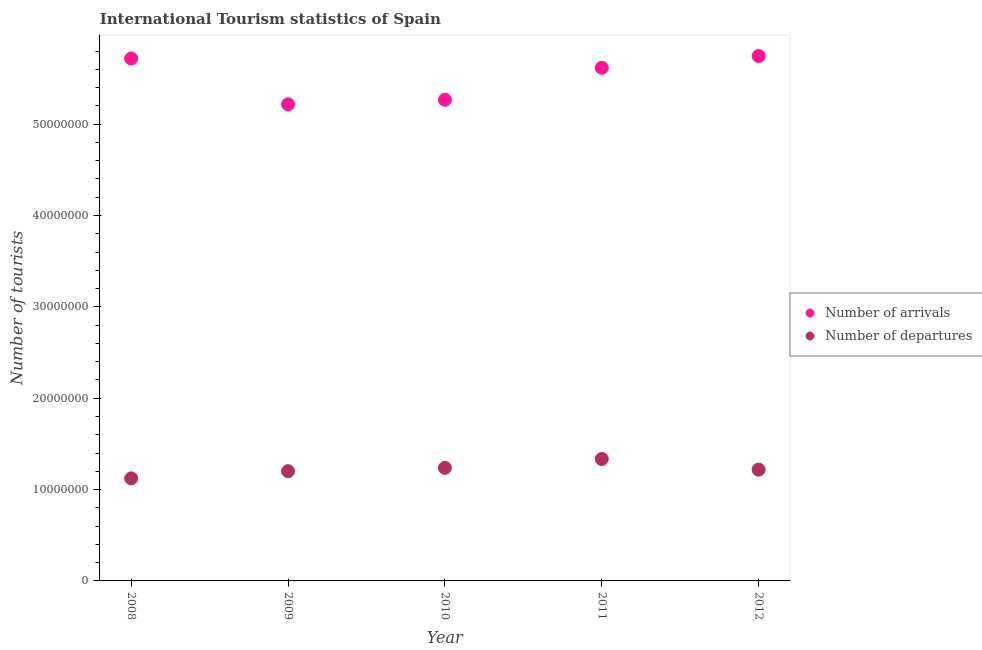Is the number of dotlines equal to the number of legend labels?
Offer a terse response. Yes. What is the number of tourist arrivals in 2008?
Your answer should be compact. 5.72e+07. Across all years, what is the maximum number of tourist arrivals?
Offer a terse response. 5.75e+07. Across all years, what is the minimum number of tourist arrivals?
Provide a succinct answer. 5.22e+07. In which year was the number of tourist arrivals maximum?
Provide a short and direct response. 2012. What is the total number of tourist arrivals in the graph?
Offer a very short reply. 2.76e+08. What is the difference between the number of tourist arrivals in 2009 and that in 2012?
Provide a succinct answer. -5.29e+06. What is the difference between the number of tourist arrivals in 2012 and the number of tourist departures in 2008?
Your response must be concise. 4.62e+07. What is the average number of tourist departures per year?
Your answer should be very brief. 1.22e+07. In the year 2008, what is the difference between the number of tourist departures and number of tourist arrivals?
Keep it short and to the point. -4.60e+07. What is the ratio of the number of tourist departures in 2009 to that in 2012?
Provide a succinct answer. 0.99. Is the number of tourist arrivals in 2008 less than that in 2010?
Give a very brief answer. No. Is the difference between the number of tourist arrivals in 2008 and 2009 greater than the difference between the number of tourist departures in 2008 and 2009?
Ensure brevity in your answer.  Yes. What is the difference between the highest and the second highest number of tourist arrivals?
Offer a very short reply. 2.72e+05. What is the difference between the highest and the lowest number of tourist arrivals?
Your answer should be compact. 5.29e+06. In how many years, is the number of tourist arrivals greater than the average number of tourist arrivals taken over all years?
Your answer should be compact. 3. Is the sum of the number of tourist arrivals in 2008 and 2010 greater than the maximum number of tourist departures across all years?
Your answer should be very brief. Yes. Does the number of tourist departures monotonically increase over the years?
Keep it short and to the point. No. Is the number of tourist arrivals strictly greater than the number of tourist departures over the years?
Your answer should be very brief. Yes. What is the difference between two consecutive major ticks on the Y-axis?
Your response must be concise. 1.00e+07. Does the graph contain grids?
Offer a terse response. No. How many legend labels are there?
Your response must be concise. 2. What is the title of the graph?
Your answer should be compact. International Tourism statistics of Spain. What is the label or title of the Y-axis?
Your answer should be very brief. Number of tourists. What is the Number of tourists in Number of arrivals in 2008?
Ensure brevity in your answer.  5.72e+07. What is the Number of tourists in Number of departures in 2008?
Keep it short and to the point. 1.12e+07. What is the Number of tourists in Number of arrivals in 2009?
Make the answer very short. 5.22e+07. What is the Number of tourists in Number of departures in 2009?
Make the answer very short. 1.20e+07. What is the Number of tourists of Number of arrivals in 2010?
Give a very brief answer. 5.27e+07. What is the Number of tourists in Number of departures in 2010?
Your answer should be very brief. 1.24e+07. What is the Number of tourists in Number of arrivals in 2011?
Your response must be concise. 5.62e+07. What is the Number of tourists of Number of departures in 2011?
Provide a short and direct response. 1.33e+07. What is the Number of tourists in Number of arrivals in 2012?
Offer a terse response. 5.75e+07. What is the Number of tourists of Number of departures in 2012?
Provide a short and direct response. 1.22e+07. Across all years, what is the maximum Number of tourists of Number of arrivals?
Your answer should be very brief. 5.75e+07. Across all years, what is the maximum Number of tourists of Number of departures?
Your answer should be compact. 1.33e+07. Across all years, what is the minimum Number of tourists of Number of arrivals?
Offer a very short reply. 5.22e+07. Across all years, what is the minimum Number of tourists of Number of departures?
Keep it short and to the point. 1.12e+07. What is the total Number of tourists in Number of arrivals in the graph?
Offer a terse response. 2.76e+08. What is the total Number of tourists in Number of departures in the graph?
Your answer should be very brief. 6.12e+07. What is the difference between the Number of tourists of Number of arrivals in 2008 and that in 2009?
Ensure brevity in your answer.  5.01e+06. What is the difference between the Number of tourists in Number of departures in 2008 and that in 2009?
Give a very brief answer. -7.88e+05. What is the difference between the Number of tourists in Number of arrivals in 2008 and that in 2010?
Make the answer very short. 4.52e+06. What is the difference between the Number of tourists in Number of departures in 2008 and that in 2010?
Your answer should be very brief. -1.15e+06. What is the difference between the Number of tourists in Number of arrivals in 2008 and that in 2011?
Keep it short and to the point. 1.02e+06. What is the difference between the Number of tourists in Number of departures in 2008 and that in 2011?
Make the answer very short. -2.12e+06. What is the difference between the Number of tourists in Number of arrivals in 2008 and that in 2012?
Your answer should be compact. -2.72e+05. What is the difference between the Number of tourists in Number of departures in 2008 and that in 2012?
Keep it short and to the point. -9.56e+05. What is the difference between the Number of tourists of Number of arrivals in 2009 and that in 2010?
Your response must be concise. -4.99e+05. What is the difference between the Number of tourists of Number of departures in 2009 and that in 2010?
Offer a very short reply. -3.62e+05. What is the difference between the Number of tourists in Number of arrivals in 2009 and that in 2011?
Ensure brevity in your answer.  -4.00e+06. What is the difference between the Number of tourists of Number of departures in 2009 and that in 2011?
Make the answer very short. -1.33e+06. What is the difference between the Number of tourists in Number of arrivals in 2009 and that in 2012?
Provide a short and direct response. -5.29e+06. What is the difference between the Number of tourists of Number of departures in 2009 and that in 2012?
Ensure brevity in your answer.  -1.68e+05. What is the difference between the Number of tourists in Number of arrivals in 2010 and that in 2011?
Your response must be concise. -3.50e+06. What is the difference between the Number of tourists in Number of departures in 2010 and that in 2011?
Offer a very short reply. -9.68e+05. What is the difference between the Number of tourists of Number of arrivals in 2010 and that in 2012?
Offer a terse response. -4.79e+06. What is the difference between the Number of tourists of Number of departures in 2010 and that in 2012?
Offer a terse response. 1.94e+05. What is the difference between the Number of tourists in Number of arrivals in 2011 and that in 2012?
Your answer should be very brief. -1.29e+06. What is the difference between the Number of tourists of Number of departures in 2011 and that in 2012?
Your answer should be compact. 1.16e+06. What is the difference between the Number of tourists of Number of arrivals in 2008 and the Number of tourists of Number of departures in 2009?
Your answer should be compact. 4.52e+07. What is the difference between the Number of tourists in Number of arrivals in 2008 and the Number of tourists in Number of departures in 2010?
Give a very brief answer. 4.48e+07. What is the difference between the Number of tourists in Number of arrivals in 2008 and the Number of tourists in Number of departures in 2011?
Keep it short and to the point. 4.38e+07. What is the difference between the Number of tourists in Number of arrivals in 2008 and the Number of tourists in Number of departures in 2012?
Offer a very short reply. 4.50e+07. What is the difference between the Number of tourists of Number of arrivals in 2009 and the Number of tourists of Number of departures in 2010?
Provide a succinct answer. 3.98e+07. What is the difference between the Number of tourists in Number of arrivals in 2009 and the Number of tourists in Number of departures in 2011?
Make the answer very short. 3.88e+07. What is the difference between the Number of tourists in Number of arrivals in 2009 and the Number of tourists in Number of departures in 2012?
Keep it short and to the point. 4.00e+07. What is the difference between the Number of tourists of Number of arrivals in 2010 and the Number of tourists of Number of departures in 2011?
Keep it short and to the point. 3.93e+07. What is the difference between the Number of tourists in Number of arrivals in 2010 and the Number of tourists in Number of departures in 2012?
Make the answer very short. 4.05e+07. What is the difference between the Number of tourists in Number of arrivals in 2011 and the Number of tourists in Number of departures in 2012?
Offer a terse response. 4.40e+07. What is the average Number of tourists in Number of arrivals per year?
Ensure brevity in your answer.  5.51e+07. What is the average Number of tourists of Number of departures per year?
Make the answer very short. 1.22e+07. In the year 2008, what is the difference between the Number of tourists in Number of arrivals and Number of tourists in Number of departures?
Your answer should be compact. 4.60e+07. In the year 2009, what is the difference between the Number of tourists in Number of arrivals and Number of tourists in Number of departures?
Your response must be concise. 4.02e+07. In the year 2010, what is the difference between the Number of tourists in Number of arrivals and Number of tourists in Number of departures?
Make the answer very short. 4.03e+07. In the year 2011, what is the difference between the Number of tourists of Number of arrivals and Number of tourists of Number of departures?
Give a very brief answer. 4.28e+07. In the year 2012, what is the difference between the Number of tourists in Number of arrivals and Number of tourists in Number of departures?
Your response must be concise. 4.53e+07. What is the ratio of the Number of tourists in Number of arrivals in 2008 to that in 2009?
Your response must be concise. 1.1. What is the ratio of the Number of tourists of Number of departures in 2008 to that in 2009?
Provide a short and direct response. 0.93. What is the ratio of the Number of tourists in Number of arrivals in 2008 to that in 2010?
Offer a very short reply. 1.09. What is the ratio of the Number of tourists of Number of departures in 2008 to that in 2010?
Your answer should be compact. 0.91. What is the ratio of the Number of tourists of Number of arrivals in 2008 to that in 2011?
Offer a very short reply. 1.02. What is the ratio of the Number of tourists in Number of departures in 2008 to that in 2011?
Your answer should be compact. 0.84. What is the ratio of the Number of tourists in Number of departures in 2008 to that in 2012?
Provide a short and direct response. 0.92. What is the ratio of the Number of tourists of Number of arrivals in 2009 to that in 2010?
Keep it short and to the point. 0.99. What is the ratio of the Number of tourists of Number of departures in 2009 to that in 2010?
Give a very brief answer. 0.97. What is the ratio of the Number of tourists of Number of arrivals in 2009 to that in 2011?
Offer a terse response. 0.93. What is the ratio of the Number of tourists in Number of departures in 2009 to that in 2011?
Ensure brevity in your answer.  0.9. What is the ratio of the Number of tourists of Number of arrivals in 2009 to that in 2012?
Provide a succinct answer. 0.91. What is the ratio of the Number of tourists of Number of departures in 2009 to that in 2012?
Your answer should be compact. 0.99. What is the ratio of the Number of tourists of Number of arrivals in 2010 to that in 2011?
Offer a terse response. 0.94. What is the ratio of the Number of tourists in Number of departures in 2010 to that in 2011?
Give a very brief answer. 0.93. What is the ratio of the Number of tourists of Number of departures in 2010 to that in 2012?
Your response must be concise. 1.02. What is the ratio of the Number of tourists of Number of arrivals in 2011 to that in 2012?
Make the answer very short. 0.98. What is the ratio of the Number of tourists of Number of departures in 2011 to that in 2012?
Provide a short and direct response. 1.1. What is the difference between the highest and the second highest Number of tourists of Number of arrivals?
Offer a terse response. 2.72e+05. What is the difference between the highest and the second highest Number of tourists of Number of departures?
Give a very brief answer. 9.68e+05. What is the difference between the highest and the lowest Number of tourists in Number of arrivals?
Keep it short and to the point. 5.29e+06. What is the difference between the highest and the lowest Number of tourists of Number of departures?
Offer a very short reply. 2.12e+06. 